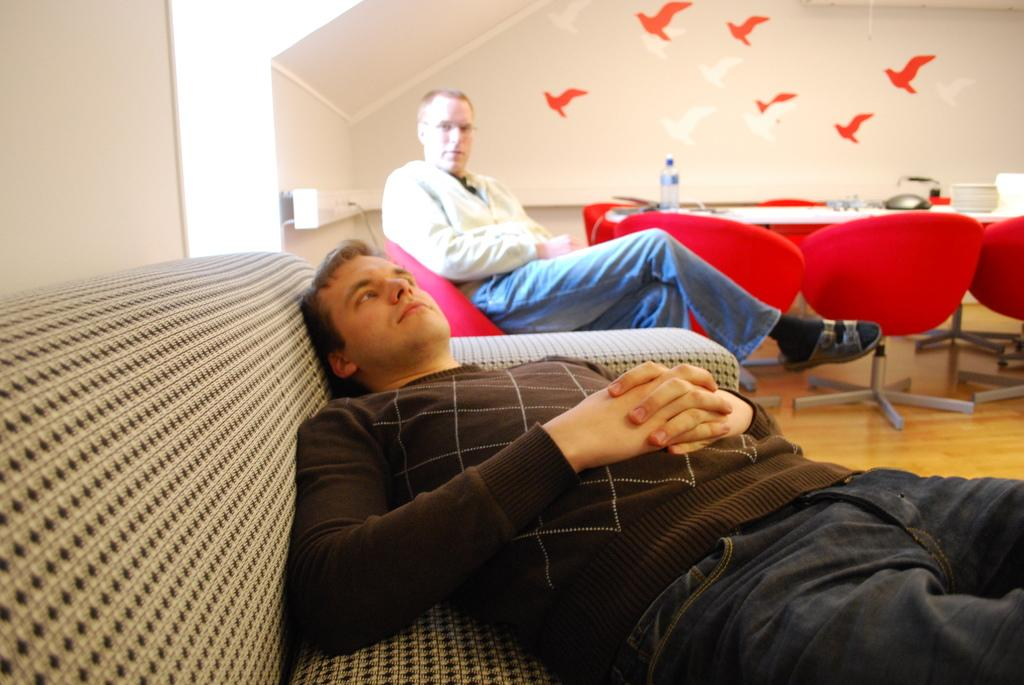How many men are in the image? There are two men in the image. What are the men doing in the image? One man is sitting on a chair, and the other man is sleeping on a sofa. What can be seen in the background of the image? There is a wall with birds in the background. What else is visible on the wall? Chairs are visible on the wall. What object can be seen on a table in the image? There is a bottle on a table in the image. What type of quiver is the man holding in the image? There is no quiver present in the image; the man is sitting on a chair. What team are the men representing in the image? There is no indication of a team or any sports activity in the image. 